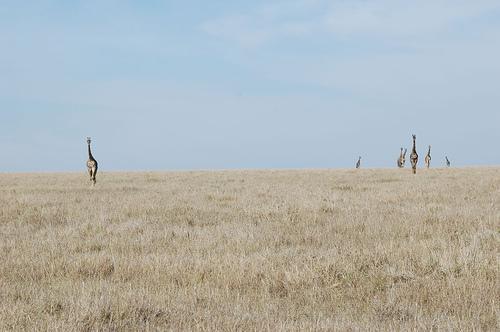How many giraffes are pictured here?
Give a very brief answer. 7. 